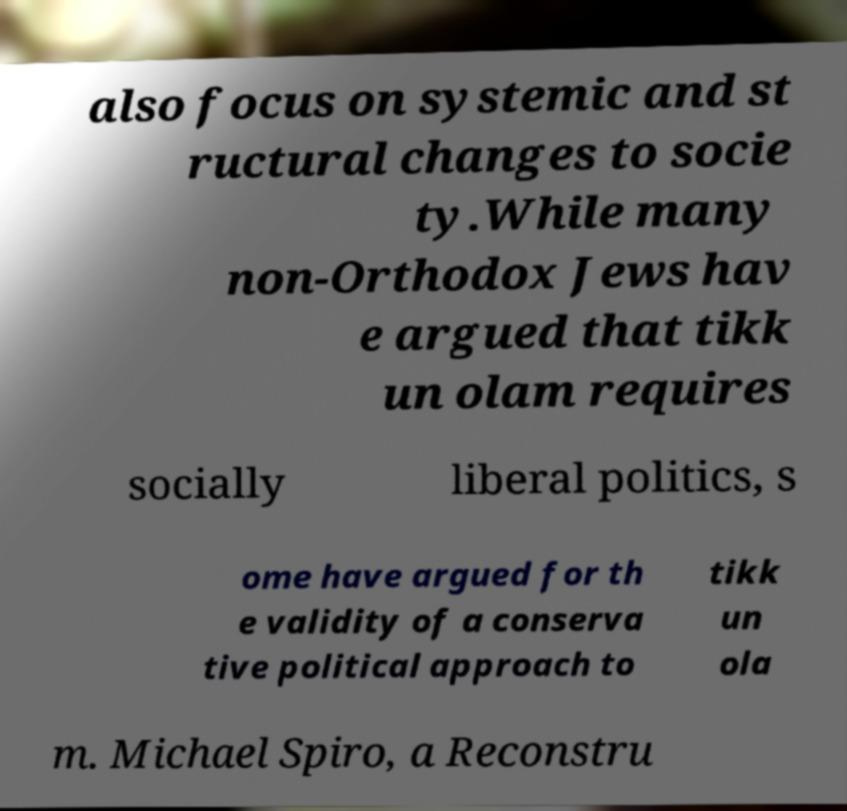I need the written content from this picture converted into text. Can you do that? also focus on systemic and st ructural changes to socie ty.While many non-Orthodox Jews hav e argued that tikk un olam requires socially liberal politics, s ome have argued for th e validity of a conserva tive political approach to tikk un ola m. Michael Spiro, a Reconstru 